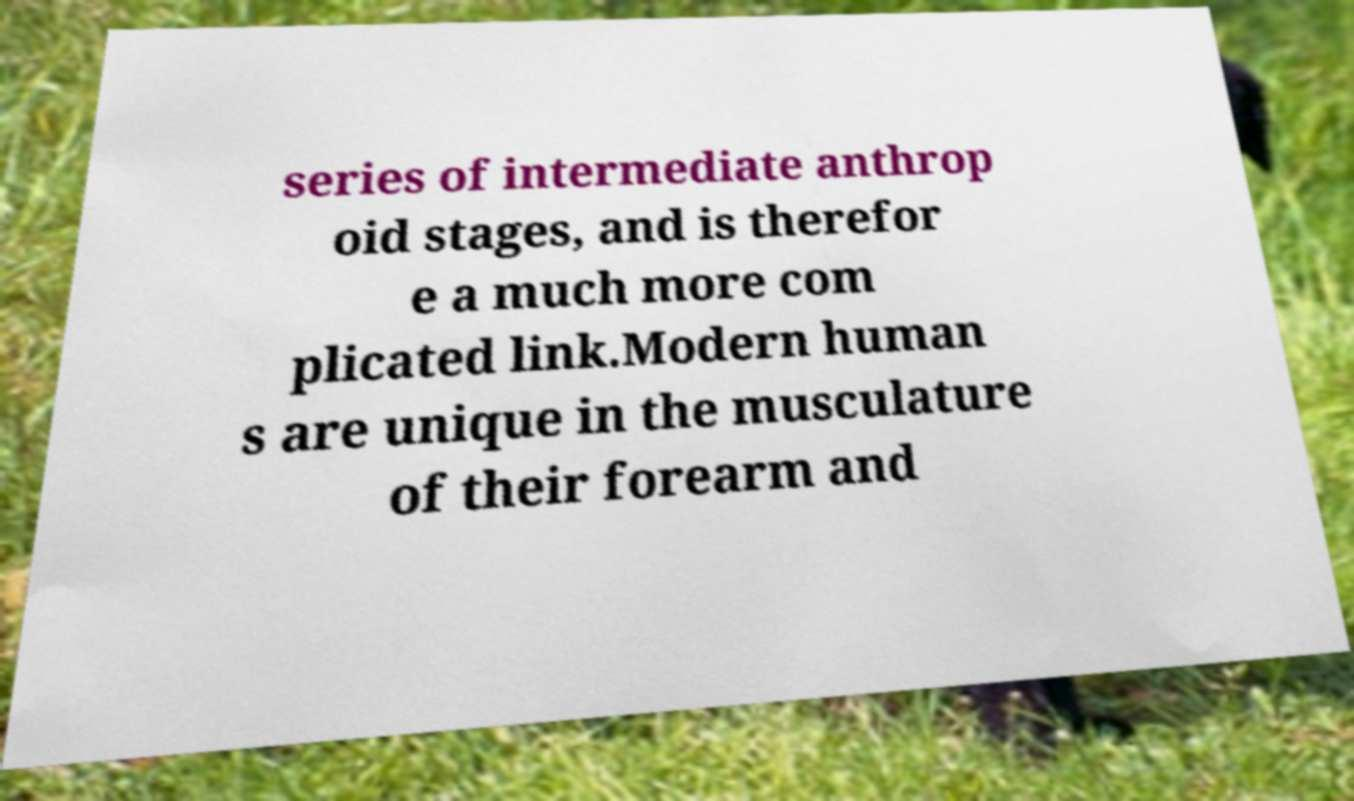Please identify and transcribe the text found in this image. series of intermediate anthrop oid stages, and is therefor e a much more com plicated link.Modern human s are unique in the musculature of their forearm and 